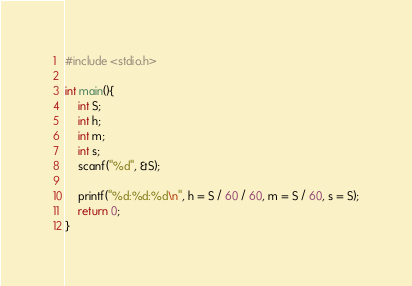Convert code to text. <code><loc_0><loc_0><loc_500><loc_500><_C_>#include <stdio.h>

int main(){
	int S;
	int h;
	int m;
	int s;
	scanf("%d", &S);
	
	printf("%d:%d:%d\n", h = S / 60 / 60, m = S / 60, s = S);
	return 0;
}</code> 